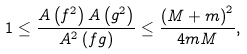<formula> <loc_0><loc_0><loc_500><loc_500>1 \leq \frac { A \left ( f ^ { 2 } \right ) A \left ( g ^ { 2 } \right ) } { A ^ { 2 } \left ( f g \right ) } \leq \frac { \left ( M + m \right ) ^ { 2 } } { 4 m M } ,</formula> 